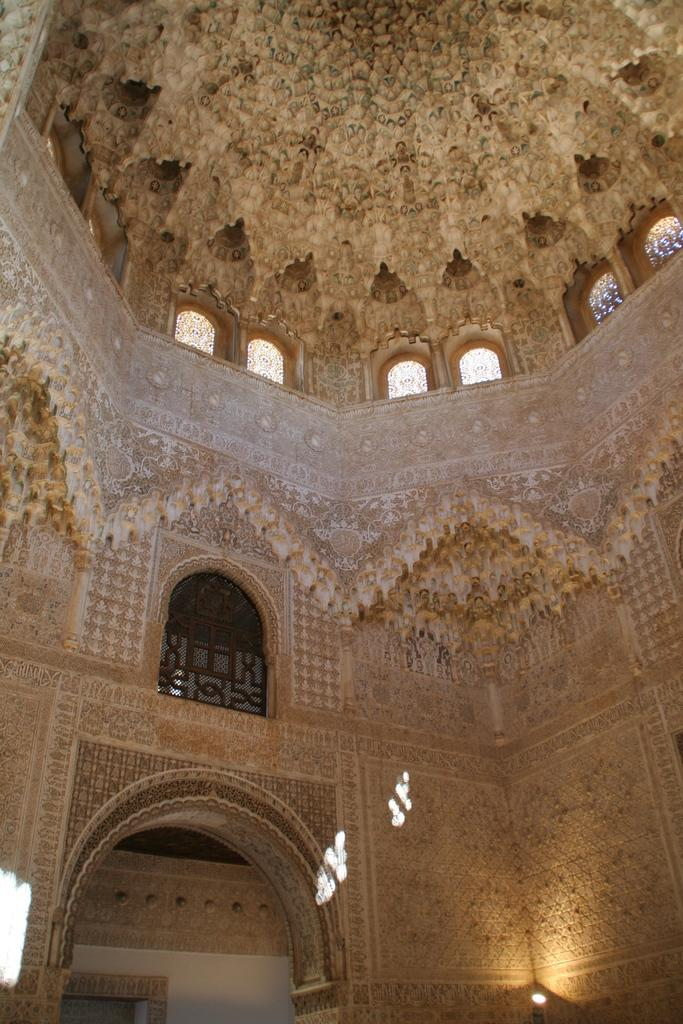What is the main feature in the foreground of the image? There is an arch in the foreground of the image. What can be observed about the design of the arch? The arch has beautiful carvings. Are there any openings in the architecture visible in the image? Yes, there are windows on the walls inside the architecture. What type of cheese is being offered by the mouth in the image? There is no mouth or cheese present in the image; it features an arch with beautiful carvings and windows on the walls. 